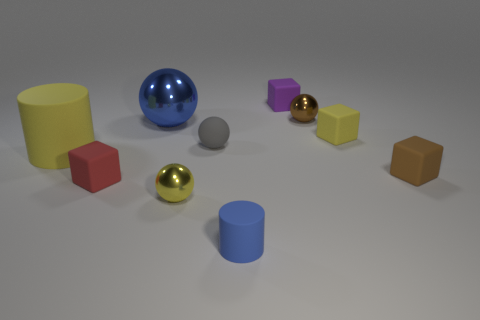Subtract all small gray spheres. How many spheres are left? 3 Subtract 1 spheres. How many spheres are left? 3 Subtract all red blocks. How many blocks are left? 3 Subtract all spheres. How many objects are left? 6 Subtract all gray cubes. Subtract all green balls. How many cubes are left? 4 Subtract all brown spheres. How many purple cylinders are left? 0 Subtract all yellow matte cylinders. Subtract all small yellow shiny balls. How many objects are left? 8 Add 1 yellow things. How many yellow things are left? 4 Add 2 cyan metal blocks. How many cyan metal blocks exist? 2 Subtract 0 blue cubes. How many objects are left? 10 